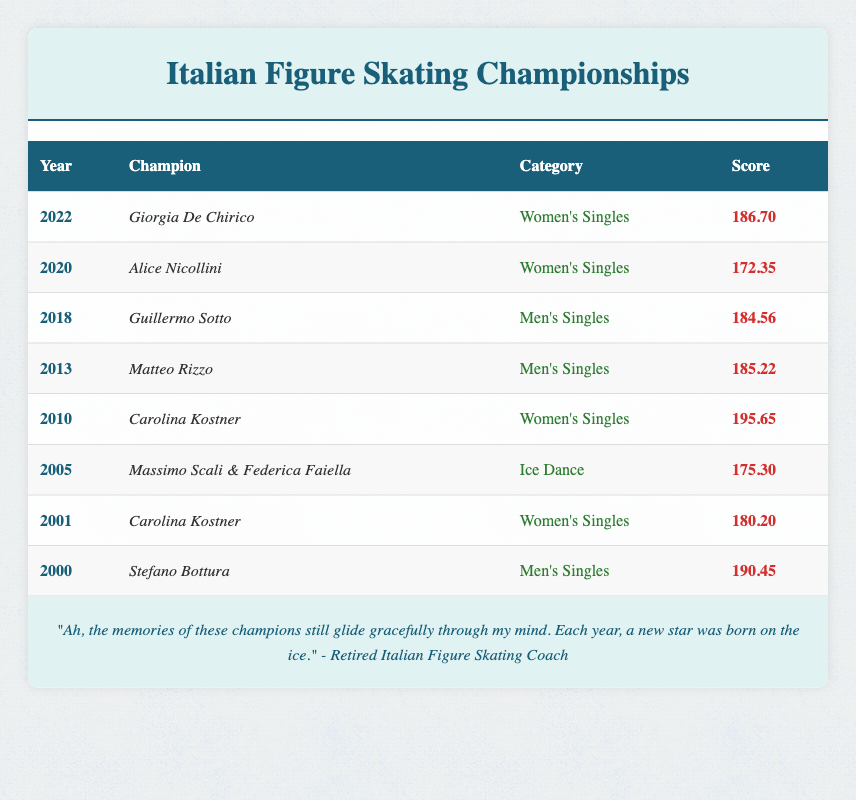What year did Carolina Kostner win her championship? Carolina Kostner won championships in two years: 2001 and 2010. Referring to the table, the respective years for her championships are clearly stated.
Answer: 2001 and 2010 Who scored higher, Guillermo Sotto or Matteo Rizzo? In the table, Guillermo Sotto's score in 2018 is 184.56, while Matteo Rizzo's score in 2013 is 185.22. By comparing these two values, we can determine who had a higher score.
Answer: Matteo Rizzo Was there any champion in the Ice Dance category? The table indicates that Massimo Scali & Federica Faiella won in the Ice Dance category in 2005. Therefore, the answer to this question can be found directly in the data.
Answer: Yes What is the average score of the Women's Singles champions? To find the average score, we sum the scores of Women's Singles champions, which are 180.20 (Carolina Kostner in 2001), 195.65 (Carolina Kostner in 2010), 172.35 (Alice Nicollini in 2020), and 186.70 (Giorgia De Chirico in 2022). Adding these scores gives us 734.90. There are 4 champions, so we divide 734.90 by 4 to get the average: 183.725.
Answer: 183.725 Which year had the highest score and who was the champion? By examining the scores in the table, we can see that the highest score is 195.65 achieved by Carolina Kostner in 2010. Thus, this year stands out for having the highest score among the champions.
Answer: 2010, Carolina Kostner 